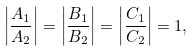<formula> <loc_0><loc_0><loc_500><loc_500>\left | \frac { A _ { 1 } } { A _ { 2 } } \right | = \left | \frac { B _ { 1 } } { B _ { 2 } } \right | = \left | \frac { C _ { 1 } } { C _ { 2 } } \right | = 1 ,</formula> 